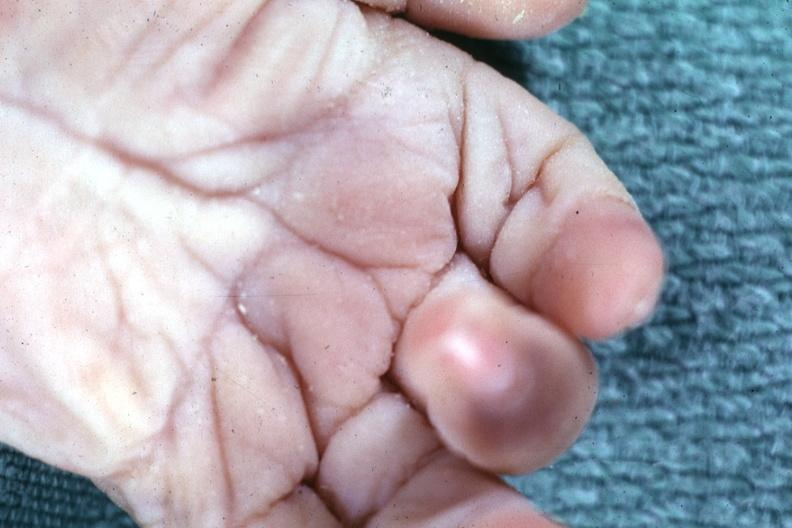what does this image show?
Answer the question using a single word or phrase. Simian crease 